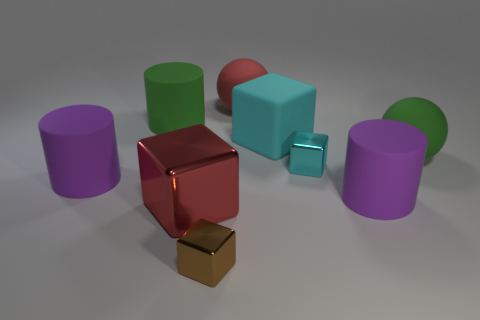Subtract all big purple cylinders. How many cylinders are left? 1 Subtract all spheres. How many objects are left? 7 Subtract all shiny spheres. Subtract all tiny brown objects. How many objects are left? 8 Add 3 blocks. How many blocks are left? 7 Add 3 metal objects. How many metal objects exist? 6 Subtract all red cubes. How many cubes are left? 3 Subtract 1 purple cylinders. How many objects are left? 8 Subtract 3 blocks. How many blocks are left? 1 Subtract all yellow cylinders. Subtract all green cubes. How many cylinders are left? 3 Subtract all yellow blocks. How many red cylinders are left? 0 